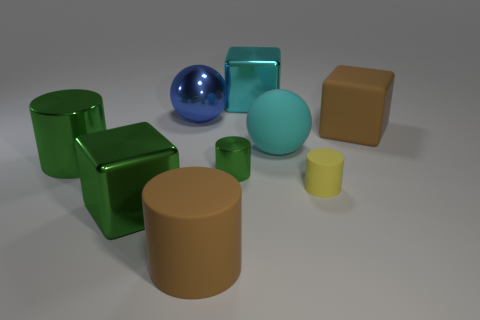Subtract all cyan metallic blocks. How many blocks are left? 2 Subtract all blue balls. How many green cylinders are left? 2 Add 1 large metallic cylinders. How many objects exist? 10 Subtract all green cylinders. How many cylinders are left? 2 Subtract all cylinders. How many objects are left? 5 Subtract 4 cylinders. How many cylinders are left? 0 Subtract all red cubes. Subtract all blue cylinders. How many cubes are left? 3 Subtract all big purple things. Subtract all cylinders. How many objects are left? 5 Add 8 big cyan objects. How many big cyan objects are left? 10 Add 8 yellow things. How many yellow things exist? 9 